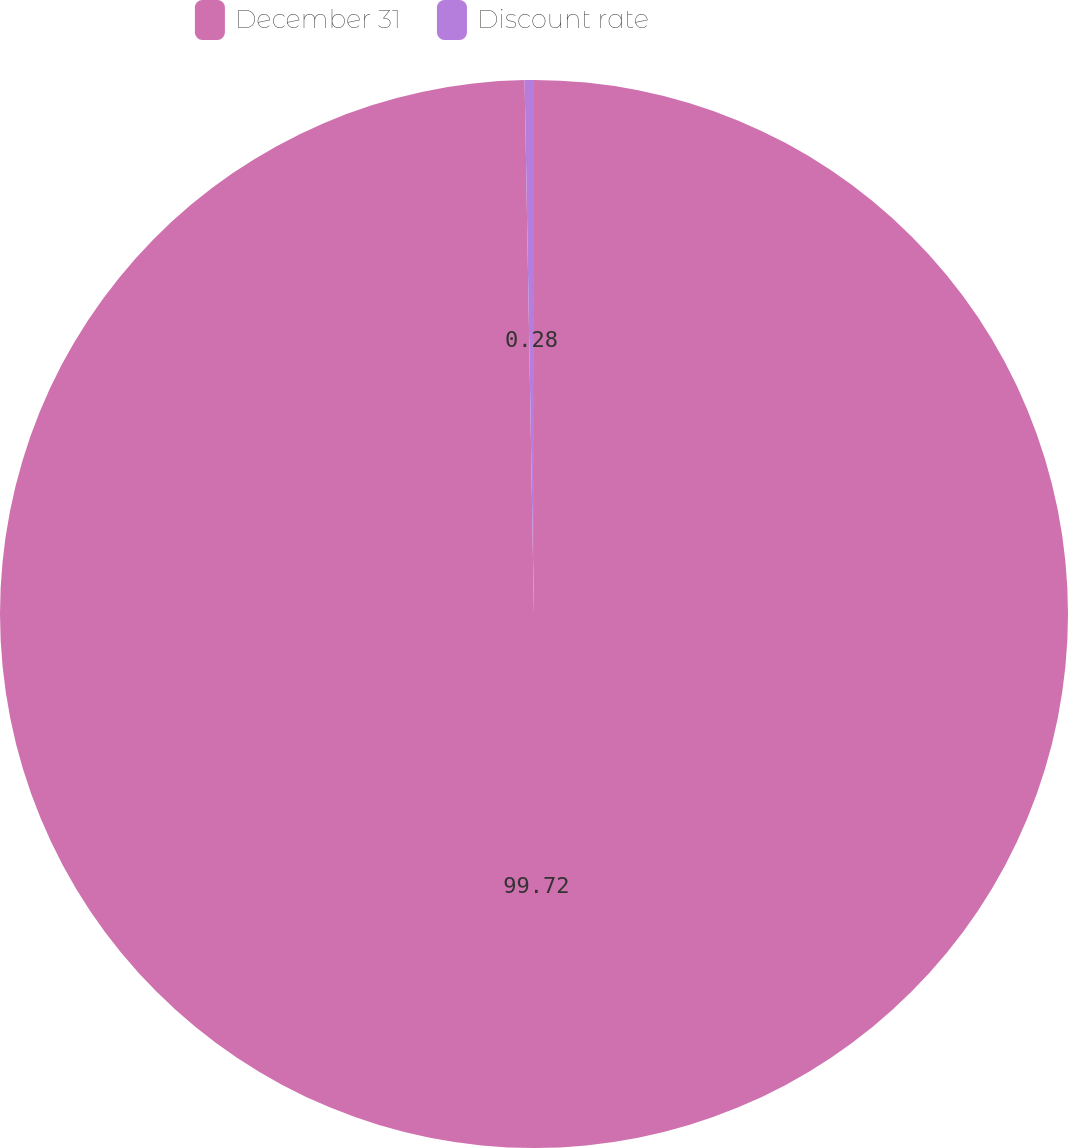<chart> <loc_0><loc_0><loc_500><loc_500><pie_chart><fcel>December 31<fcel>Discount rate<nl><fcel>99.72%<fcel>0.28%<nl></chart> 